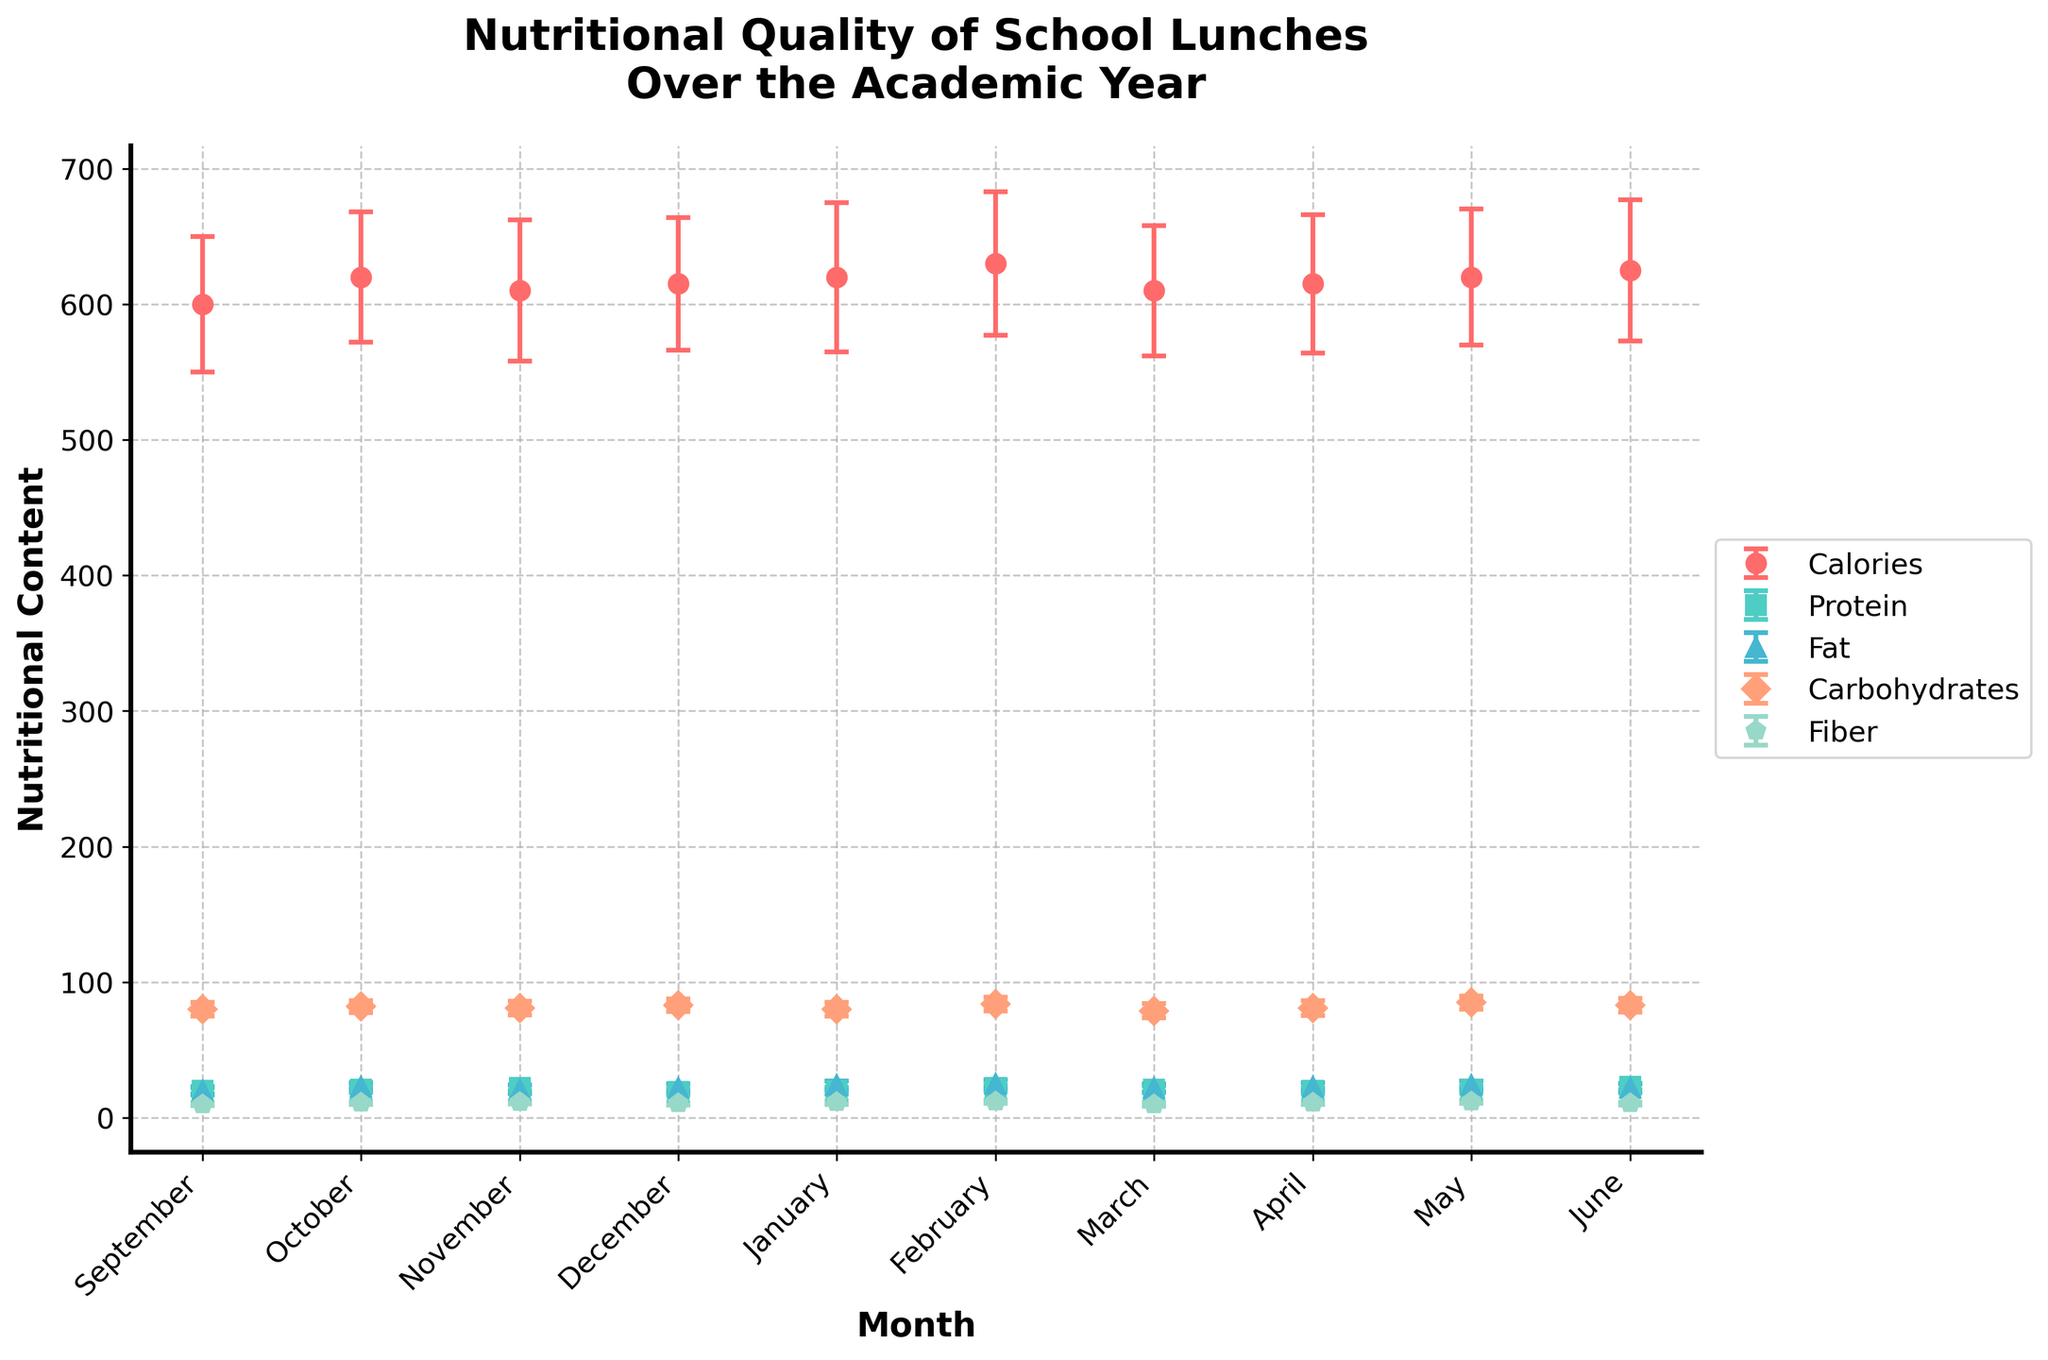What is the title of the figure? The title is usually placed at the top of the figure and provides a summary of what the figure represents. In this case, it should be clearly visible.
Answer: Nutritional Quality of School Lunches Over the Academic Year What is the nutritional content with the highest mean value in February? Look for the data points representing February and identify the nutritional content with the highest mean value.
Answer: Carbohydrates Which month has the highest mean protein content? Look along the Protein line across all months and identify the peak value.
Answer: June What is the trend in the mean calories from September to June? Observe the pattern of the Calories line from September to June to identify if it generally increases, decreases, or stays the same.
Answer: Slightly increases How much does the mean fiber content change from October to November? Calculate the difference between the fiber means for October and November.
Answer: 0.5 In which month do we see the lowest mean fat content? Identify the month where the Fat line dips to its lowest point.
Answer: September Which nutritional content shows the most variability (highest error bars) across the year? Observe the height of the error bars and identify which nutrient consistently has the largest error bars across all months.
Answer: Fat Compare the mean calories in December and March. Which month is higher? Identify the mean values for Calories in December and March and compare them to see which is higher.
Answer: December In which month is the mean carbohydrates content the highest? Look along the Carbohydrates line across all months and identify the peak value.
Answer: May Is there a month where the mean fiber content is the same as any other nutrient's mean? If so, which and when? Compare the fiber value of each month to the values of other nutrients to find any matching values.
Answer: May (Fiber and Protein both at 12) 